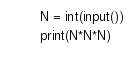Convert code to text. <code><loc_0><loc_0><loc_500><loc_500><_Python_>
N = int(input())
print(N*N*N)</code> 